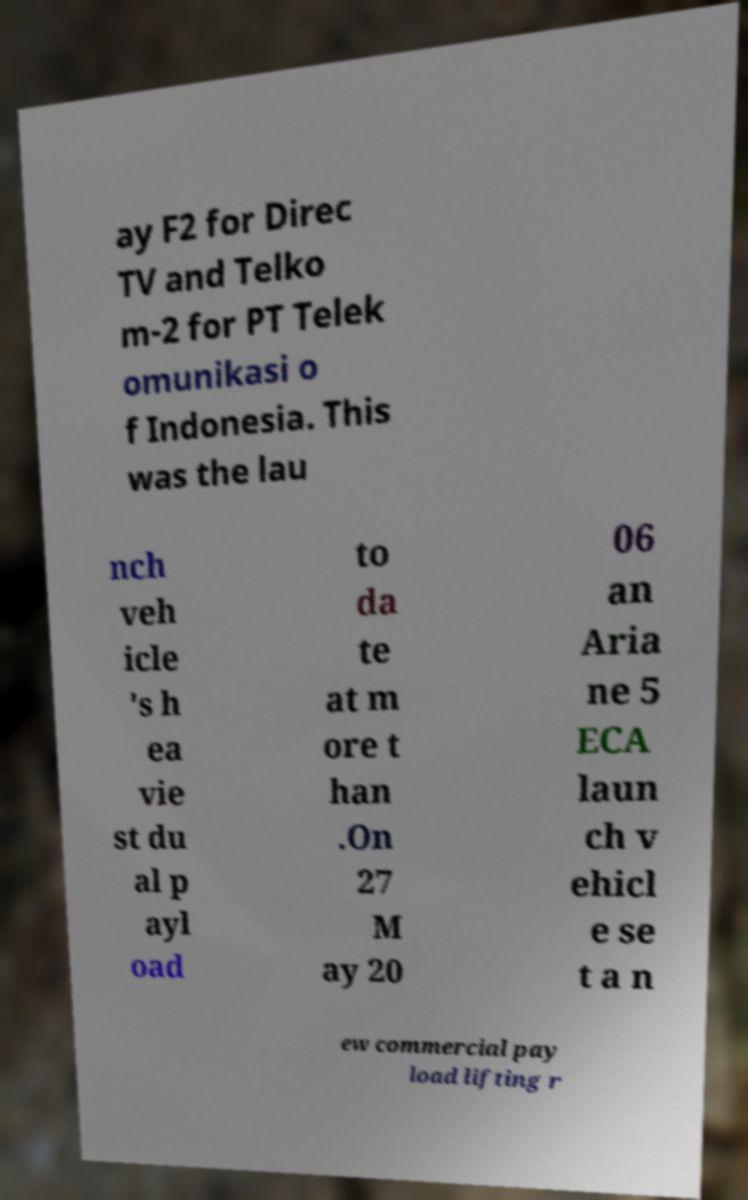Could you extract and type out the text from this image? ay F2 for Direc TV and Telko m-2 for PT Telek omunikasi o f Indonesia. This was the lau nch veh icle 's h ea vie st du al p ayl oad to da te at m ore t han .On 27 M ay 20 06 an Aria ne 5 ECA laun ch v ehicl e se t a n ew commercial pay load lifting r 